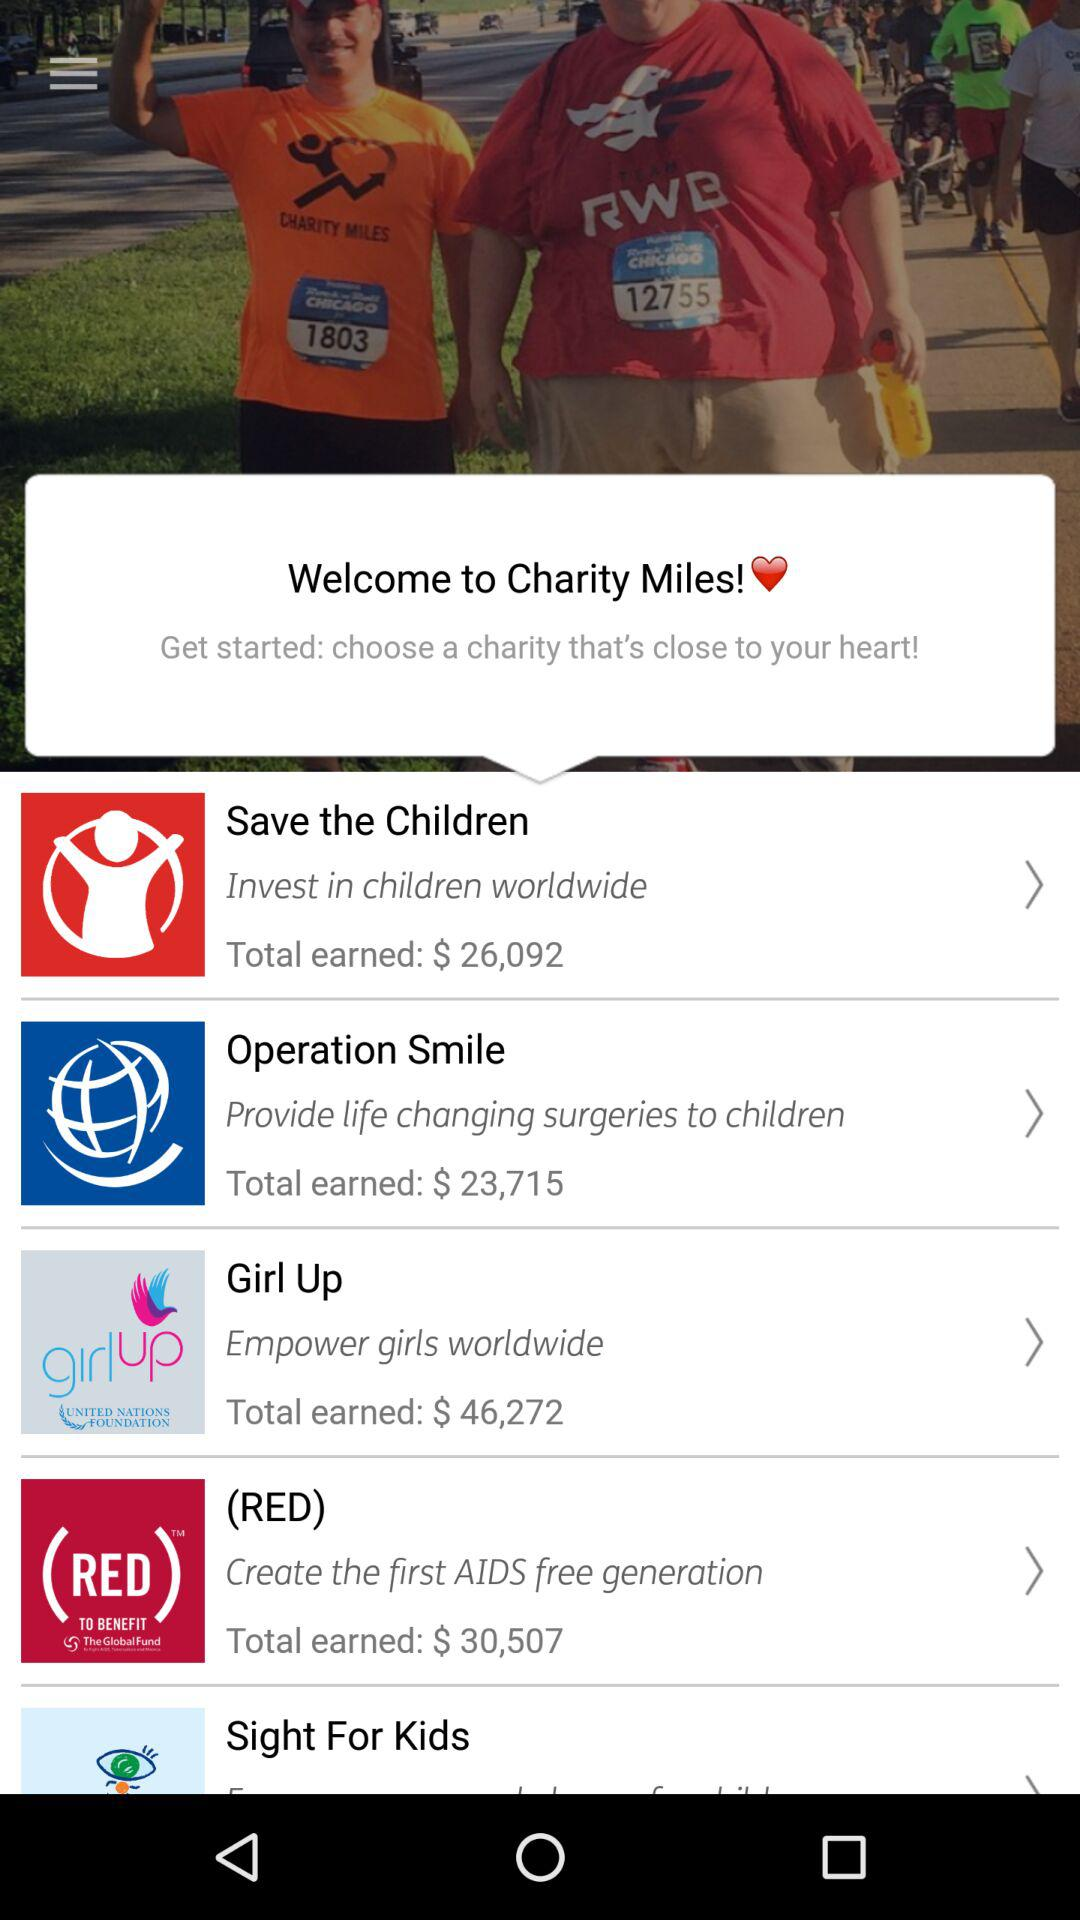How much is the total amount earned for "Girl Up"? The total amount earned for "Girl Up" is $46,272. 